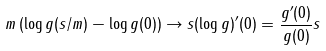Convert formula to latex. <formula><loc_0><loc_0><loc_500><loc_500>m \left ( \log g ( s / m ) - \log g ( 0 ) \right ) \to s ( \log g ) ^ { \prime } ( 0 ) = \frac { g ^ { \prime } ( 0 ) } { g ( 0 ) } s</formula> 